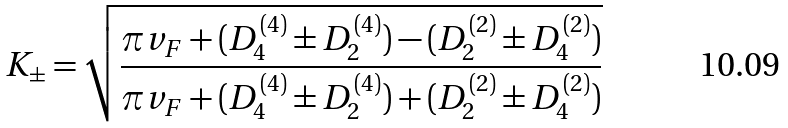<formula> <loc_0><loc_0><loc_500><loc_500>K _ { \pm } = \sqrt { \frac { \pi v _ { F } + ( D _ { 4 } ^ { ( 4 ) } \pm D _ { 2 } ^ { ( 4 ) } ) - ( D _ { 2 } ^ { ( 2 ) } \pm D _ { 4 } ^ { ( 2 ) } ) } { \pi v _ { F } + ( D _ { 4 } ^ { ( 4 ) } \pm D _ { 2 } ^ { ( 4 ) } ) + ( D _ { 2 } ^ { ( 2 ) } \pm D _ { 4 } ^ { ( 2 ) } ) } }</formula> 